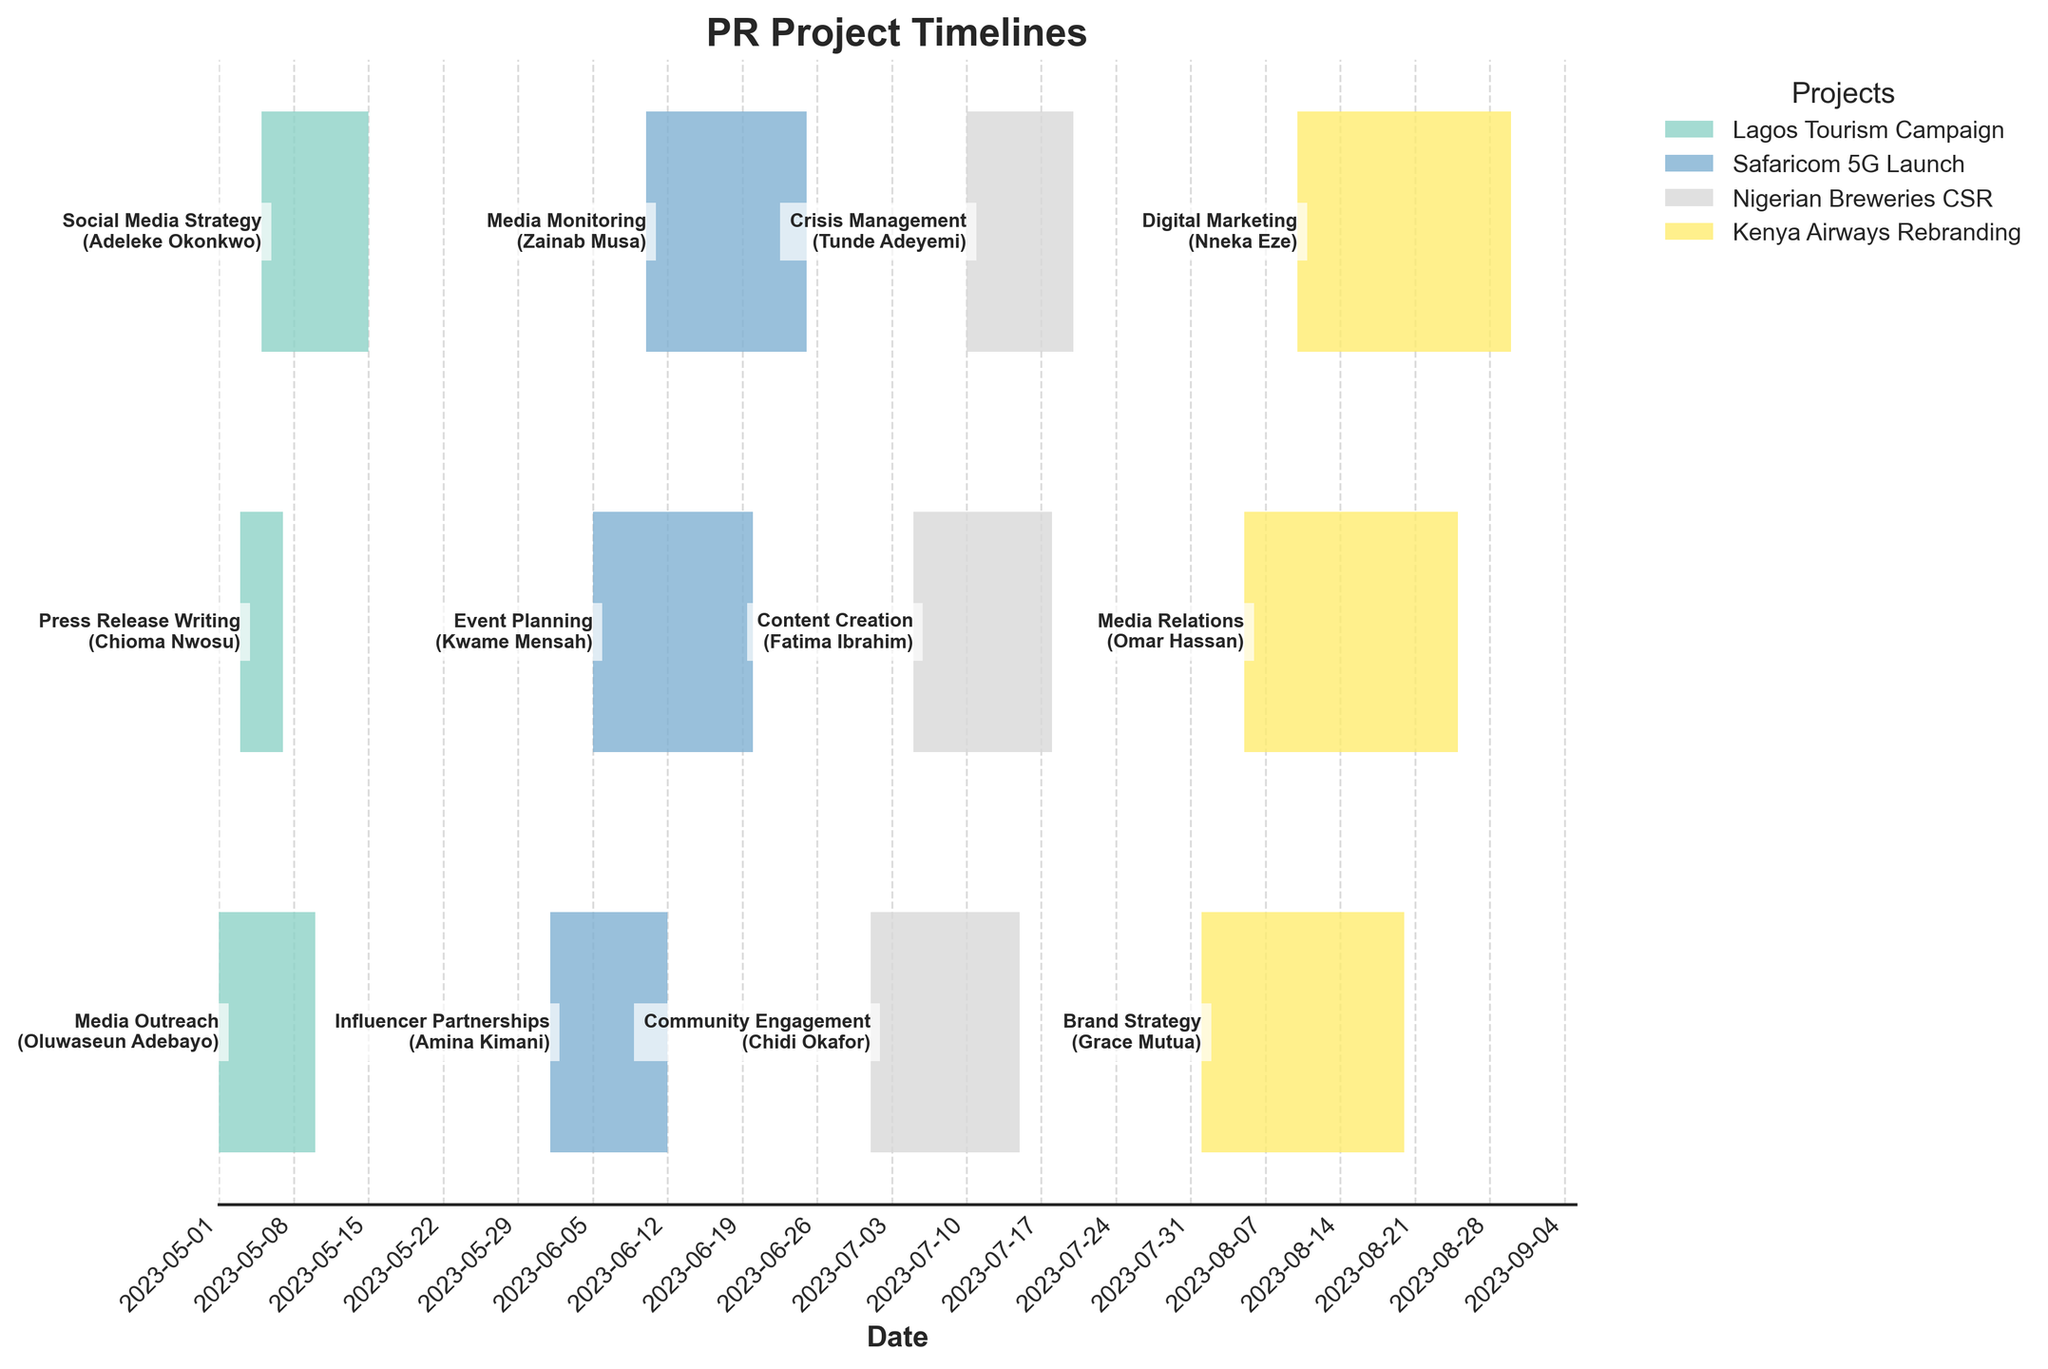What is the title of the plot? The title is usually at the top of the figure and gives an overview of what the plot is about.
Answer: PR Project Timelines Which project had the task starting earliest? By looking at the leftmost bar on the x-axis, we can see which task started first.
Answer: Lagos Tourism Campaign Who is responsible for the 'Digital Marketing' task in the 'Kenya Airways Rebranding' project? Locate the 'Kenya Airways Rebranding' project, then identify the 'Digital Marketing' task and read the corresponding employee's name.
Answer: Nneka Eze How long did the 'Press Release Writing' task take to complete? Check the 'Lagos Tourism Campaign' project and look for the 'Press Release Writing' task. Subtract the start date from the end date. (May 7 - May 3).
Answer: 4 days Which project has the most overlapping tasks? Examine the bars in each project to see which one has the most tasks starting and ending over the same period.
Answer: Safaricom 5G Launch Which employee has the longest task duration in the 'Kenya Airways Rebranding' project? Check the durations of tasks under 'Kenya Airways Rebranding' and determine the longest bar.
Answer: Grace Mutua Compare the total duration of tasks in 'Nigerian Breweries CSR' and 'Kenya Airways Rebranding'. Which project has a longer total duration? Sum up the durations of each task in both projects and compare the totals. (14 + 13 + 10 and 19 + 20 + 20). Nigerian Breweries CSR: 37 days, Kenya Airways Rebranding: 59 days
Answer: Kenya Airways Rebranding Which employee completed their task within the shortest amount of time? Identify the shortest bar across all projects and find the corresponding employee name.
Answer: Chioma Nwosu What is the average duration of tasks in the 'Safaricom 5G Launch' project? Calculate the sum of durations for all tasks in this project and divide by the number of tasks. Durations: 12, 15, 15. (12 + 15 + 15) / 3 = 14 days
Answer: 14 days Between 'Event Planning' and 'Crisis Management', which task ended later? Compare the end dates of these two tasks in their respective projects. (June 20 and July 20)
Answer: Crisis Management 